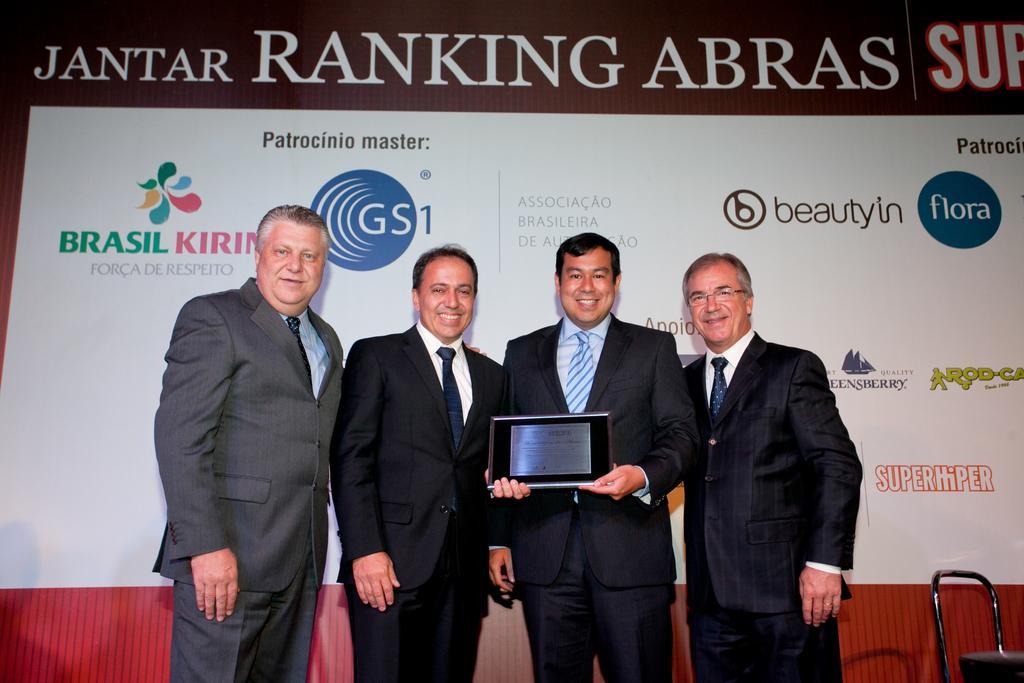Can you describe this image briefly? In this image there are four men standing towards the bottom of the image, there are two men holding an object, there is an object towards the bottom of the image, there is a board behind the persons, there is text on the board. 